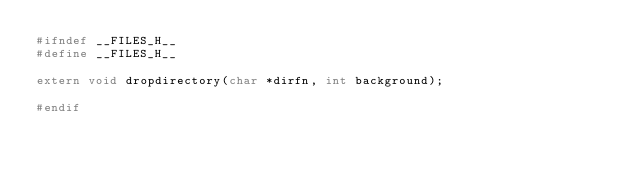Convert code to text. <code><loc_0><loc_0><loc_500><loc_500><_C_>#ifndef __FILES_H__
#define __FILES_H__

extern void dropdirectory(char *dirfn, int background);

#endif

</code> 